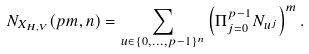<formula> <loc_0><loc_0><loc_500><loc_500>N _ { X _ { H , V } } ( p m , n ) = \sum _ { u \in \{ 0 , \dots , p - 1 \} ^ { n } } \left ( \Pi _ { j = 0 } ^ { p - 1 } N _ { u ^ { j } } \right ) ^ { m } .</formula> 